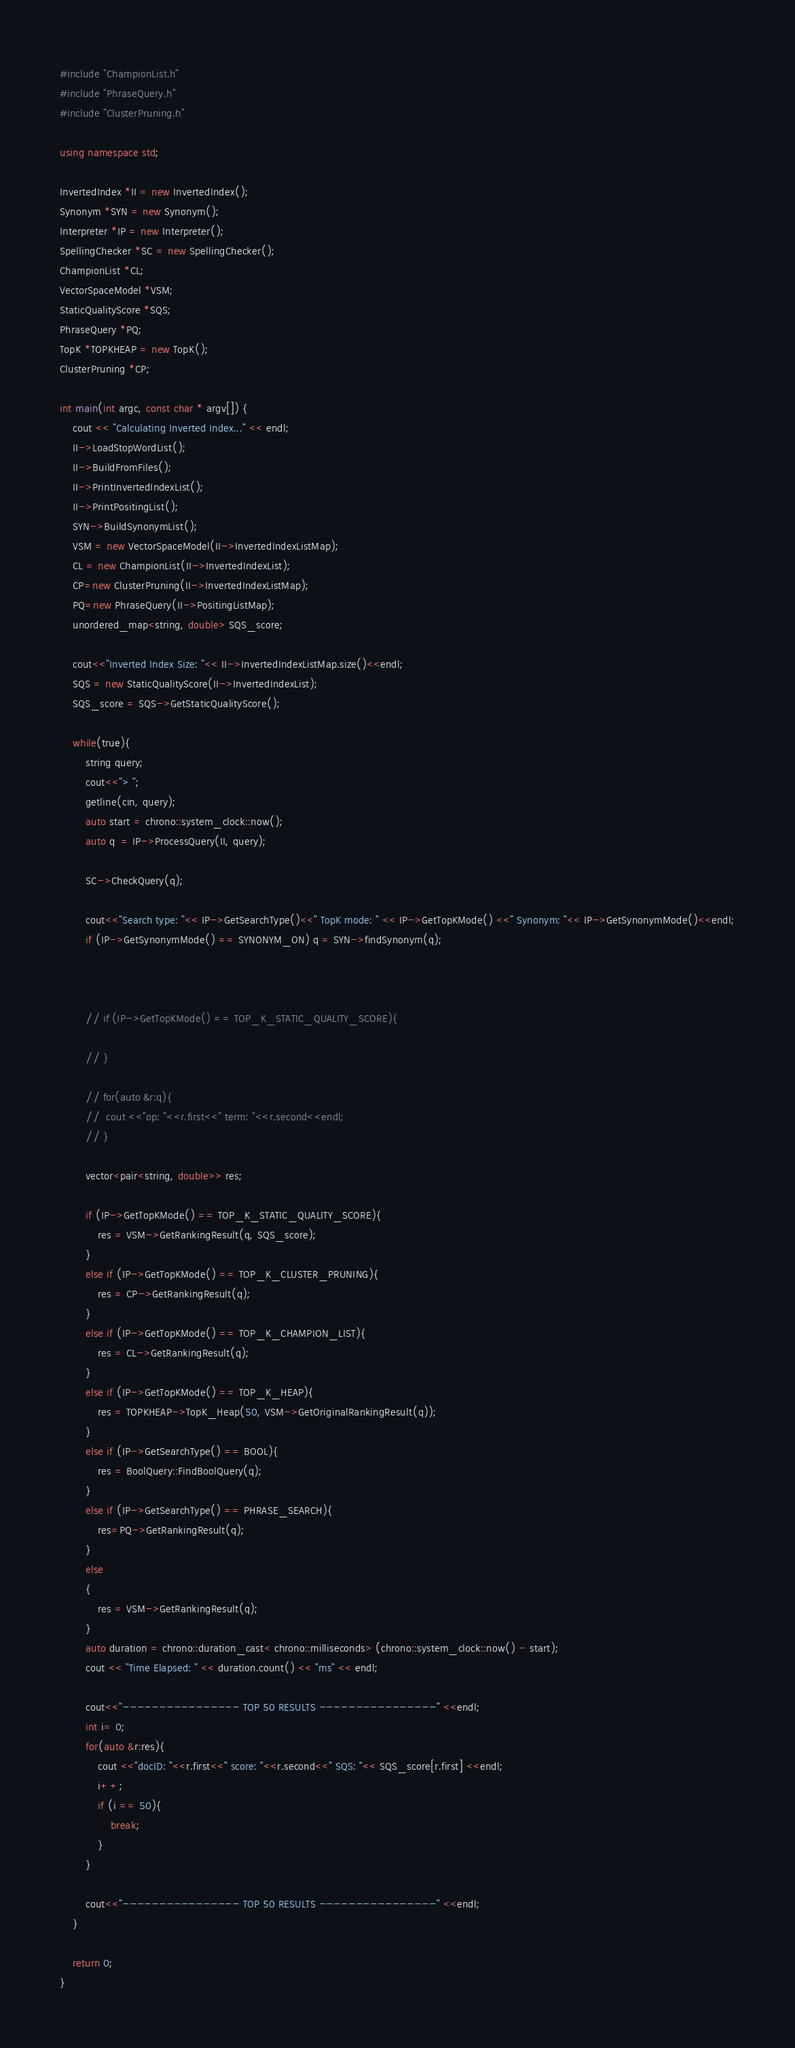<code> <loc_0><loc_0><loc_500><loc_500><_C++_>#include "ChampionList.h"
#include "PhraseQuery.h"
#include "ClusterPruning.h"

using namespace std;

InvertedIndex *II = new InvertedIndex();
Synonym *SYN = new Synonym();
Interpreter *IP = new Interpreter();
SpellingChecker *SC = new SpellingChecker();
ChampionList *CL;
VectorSpaceModel *VSM;
StaticQualityScore *SQS;
PhraseQuery *PQ;
TopK *TOPKHEAP = new TopK();
ClusterPruning *CP;

int main(int argc, const char * argv[]) {
	cout << "Calculating Inverted Index..." << endl;
	II->LoadStopWordList();
	II->BuildFromFiles();
	II->PrintInvertedIndexList();
	II->PrintPositingList();
	SYN->BuildSynonymList();
	VSM = new VectorSpaceModel(II->InvertedIndexListMap);
	CL = new ChampionList(II->InvertedIndexList);
	CP=new ClusterPruning(II->InvertedIndexListMap);
	PQ=new PhraseQuery(II->PositingListMap);
	unordered_map<string, double> SQS_score;

	cout<<"Inverted Index Size: "<< II->InvertedIndexListMap.size()<<endl;
	SQS = new StaticQualityScore(II->InvertedIndexList);
	SQS_score = SQS->GetStaticQualityScore();
	
	while(true){
		string query;
		cout<<"> ";
		getline(cin, query);
		auto start = chrono::system_clock::now();
		auto q  = IP->ProcessQuery(II, query);

		SC->CheckQuery(q);

		cout<<"Search type: "<< IP->GetSearchType()<<" TopK mode: " << IP->GetTopKMode() <<" Synonym: "<< IP->GetSynonymMode()<<endl;
		if (IP->GetSynonymMode() == SYNONYM_ON) q = SYN->findSynonym(q);


		
		// if (IP->GetTopKMode() == TOP_K_STATIC_QUALITY_SCORE){
			
		// }

		// for(auto &r:q){
		// 	cout <<"op: "<<r.first<<" term: "<<r.second<<endl;
		// }

		vector<pair<string, double>> res;

		if (IP->GetTopKMode() == TOP_K_STATIC_QUALITY_SCORE){
			res = VSM->GetRankingResult(q, SQS_score);
		}
		else if (IP->GetTopKMode() == TOP_K_CLUSTER_PRUNING){        
			res = CP->GetRankingResult(q);
		}
		else if (IP->GetTopKMode() == TOP_K_CHAMPION_LIST){
			res = CL->GetRankingResult(q);
		}
		else if (IP->GetTopKMode() == TOP_K_HEAP){
			res = TOPKHEAP->TopK_Heap(50, VSM->GetOriginalRankingResult(q));
		}
		else if (IP->GetSearchType() == BOOL){
			res = BoolQuery::FindBoolQuery(q);
		}
		else if (IP->GetSearchType() == PHRASE_SEARCH){
			res=PQ->GetRankingResult(q);
		}
		else
		{
			res = VSM->GetRankingResult(q);
		}
		auto duration = chrono::duration_cast< chrono::milliseconds> (chrono::system_clock::now() - start);
		cout << "Time Elapsed: " << duration.count() << "ms" << endl;

		cout<<"---------------- TOP 50 RESULTS ----------------" <<endl;
		int i= 0;
		for(auto &r:res){
			cout <<"docID: "<<r.first<<" score: "<<r.second<<" SQS: "<< SQS_score[r.first] <<endl;
			i++;
			if (i == 50){
				break;
			}
		}

		cout<<"---------------- TOP 50 RESULTS ----------------" <<endl;
	}

	return 0;
}
</code> 